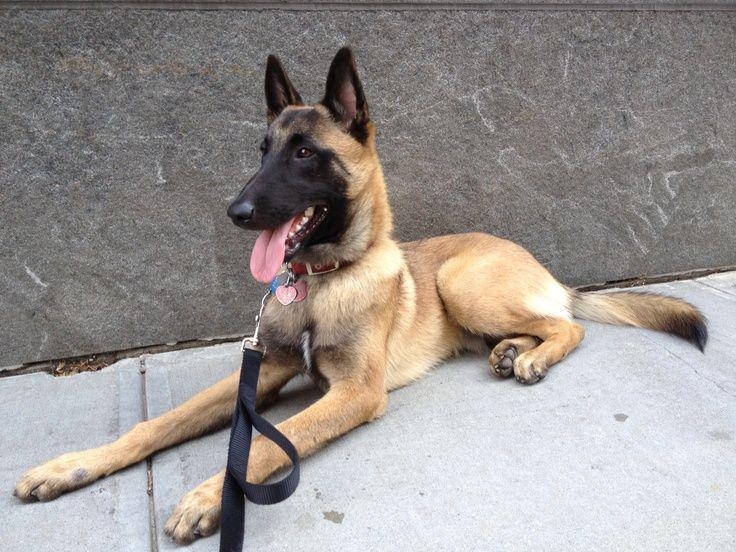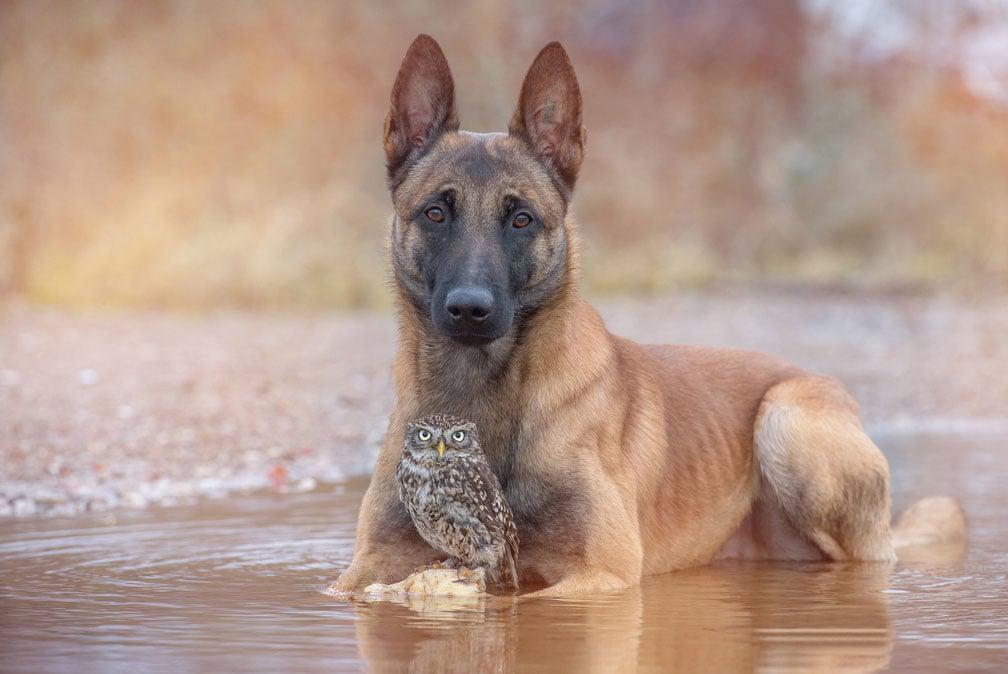The first image is the image on the left, the second image is the image on the right. For the images shown, is this caption "One of the dogs has it's tongue hanging out and neither of the dogs is a puppy." true? Answer yes or no. Yes. 